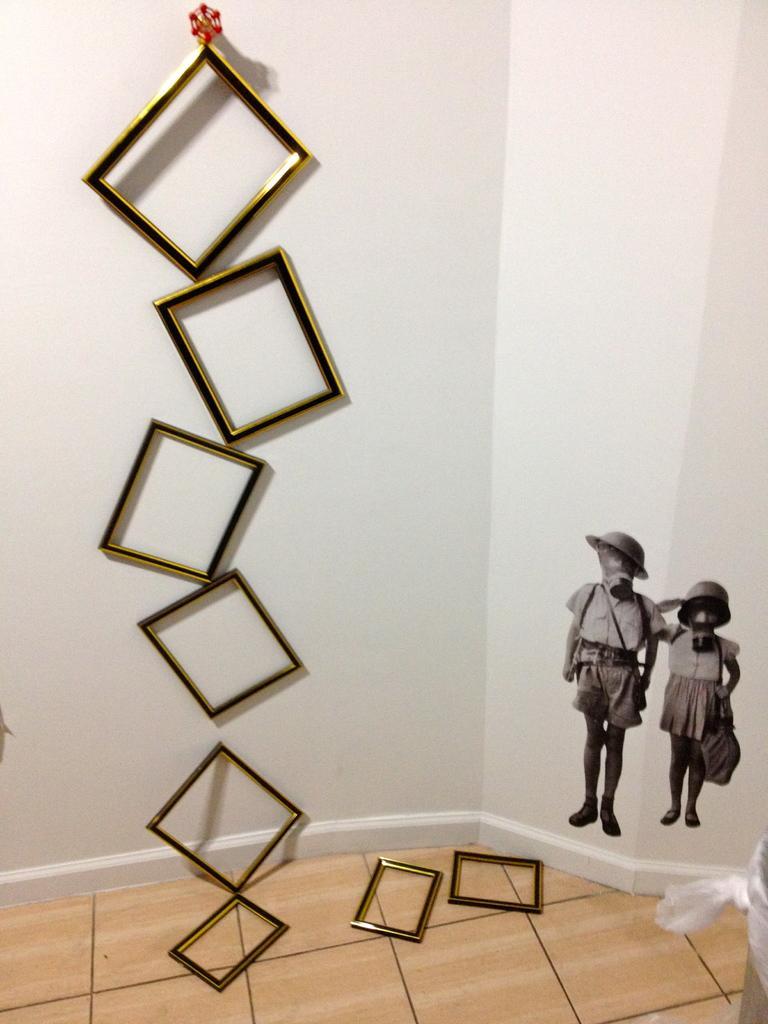In one or two sentences, can you explain what this image depicts? In the foreground of this image, there are frames on the wall and also few are on the floor. On the right, there are stickers on the wall and also an object on the right bottom. 